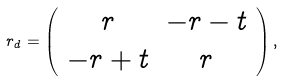<formula> <loc_0><loc_0><loc_500><loc_500>r _ { d } = \left ( \begin{array} { c c } r & - r - t \\ - r + t & r \end{array} \right ) ,</formula> 